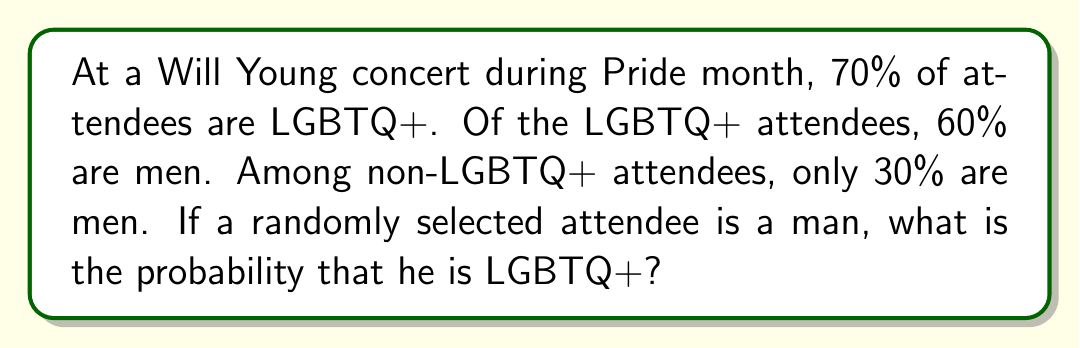Could you help me with this problem? Let's approach this using Bayes' theorem:

1) Define events:
   L: Attendee is LGBTQ+
   M: Attendee is a man

2) Given probabilities:
   P(L) = 0.70
   P(M|L) = 0.60
   P(M|not L) = 0.30

3) We want to find P(L|M). Bayes' theorem states:

   $$P(L|M) = \frac{P(M|L) \cdot P(L)}{P(M)}$$

4) We need to calculate P(M) using the law of total probability:

   $$P(M) = P(M|L) \cdot P(L) + P(M|not L) \cdot P(not L)$$
   $$P(M) = 0.60 \cdot 0.70 + 0.30 \cdot 0.30 = 0.42 + 0.09 = 0.51$$

5) Now we can apply Bayes' theorem:

   $$P(L|M) = \frac{0.60 \cdot 0.70}{0.51} = \frac{0.42}{0.51} \approx 0.8235$$

6) Convert to percentage: 0.8235 * 100 ≈ 82.35%
Answer: 82.35% 